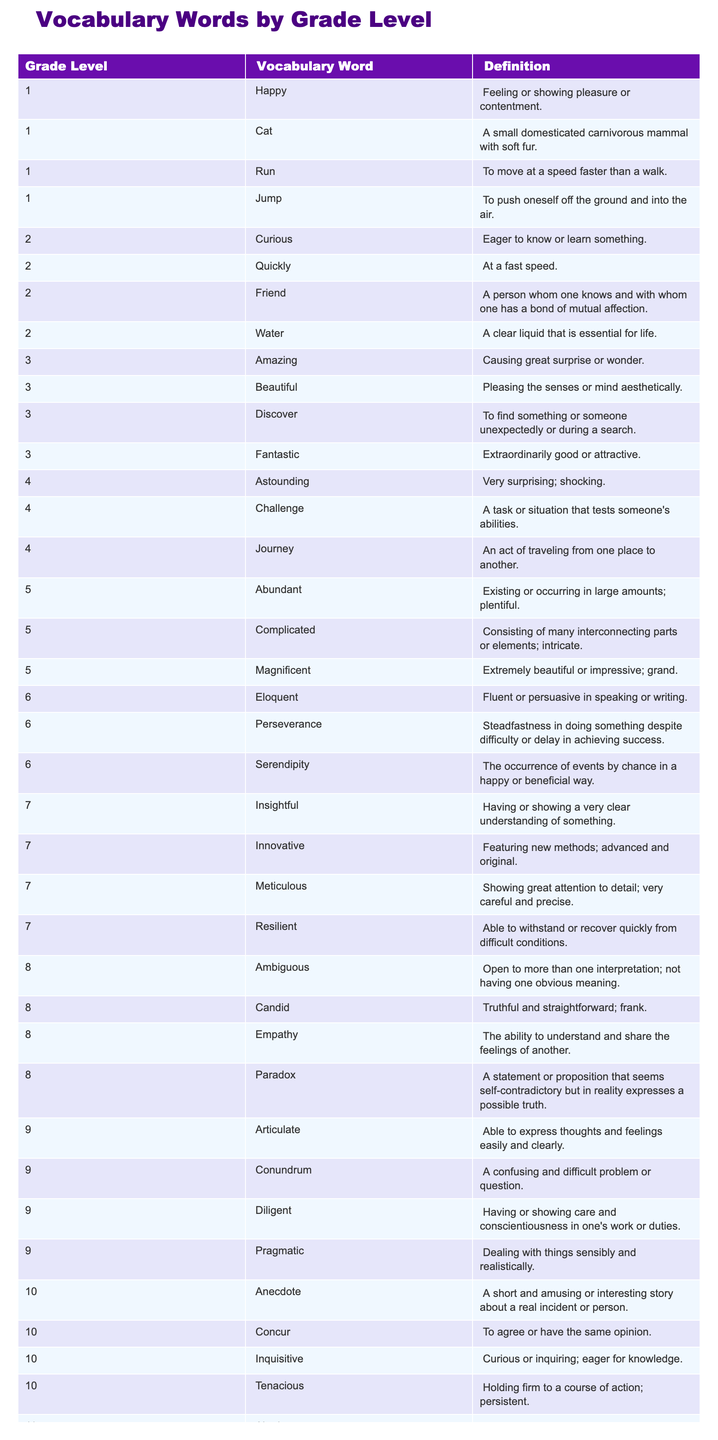What is the vocabulary word for Grade 1 that means "to move at a speed faster than a walk"? Looking at the table, the vocabulary word listed under Grade 1 that fits this definition is "Run."
Answer: Run Which Grade has the word "Empathy"? By scanning the Grade Level column, "Empathy" is listed under Grade 8.
Answer: Grade 8 How many vocabulary words are defined for Grade 5? According to the table, there are 3 words listed for Grade 5: "Abundant," "Complicated," and "Magnificent."
Answer: 3 Is "Altruism" a word found in Grade 10? Checking the table, "Altruism" appears in Grade 11, not Grade 10.
Answer: No Which word in Grade 4 means "a task that tests someone's abilities"? From the table, the word that means this in Grade 4 is "Challenge."
Answer: Challenge What is the definition of "Beautiful" in Grade 3? Referring to Grade 3 in the table, "Beautiful" is defined as "Pleasing the senses or mind aesthetically."
Answer: Pleasing the senses or mind aesthetically In which grade level is the word "Tenacious" found? Looking through the table, "Tenacious" is listed under Grade 10.
Answer: Grade 10 How many total vocabulary words are listed for Grade 2 and Grade 3 combined? For Grade 2, there are 4 words and for Grade 3, there are 4 words, summing them gives 4 + 4 = 8.
Answer: 8 What is the word associated with the definition "the occurrence of events by chance in a happy or beneficial way"? In the table, this definition corresponds to the word "Serendipity," which is found in Grade 6.
Answer: Serendipity Are there any vocabulary words in Grade 7 that start with the letter 'M'? By scanning Grade 7, the words "Meticulous" and "M" starts with "M," indicating there is.
Answer: Yes 